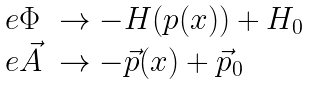Convert formula to latex. <formula><loc_0><loc_0><loc_500><loc_500>\begin{array} { l l } e \Phi & \rightarrow - H ( p ( x ) ) + H _ { 0 } \\ e \vec { A } & \rightarrow - \vec { p } ( x ) + \vec { p } _ { 0 } \end{array}</formula> 